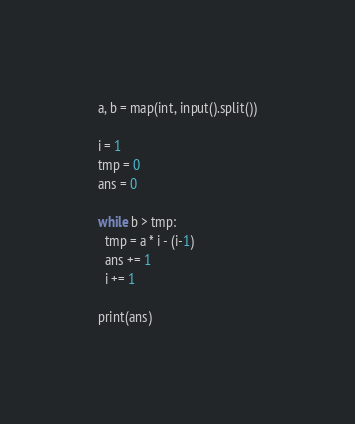<code> <loc_0><loc_0><loc_500><loc_500><_Python_>a, b = map(int, input().split())

i = 1
tmp = 0
ans = 0

while b > tmp:
  tmp = a * i - (i-1)
  ans += 1
  i += 1

print(ans)</code> 